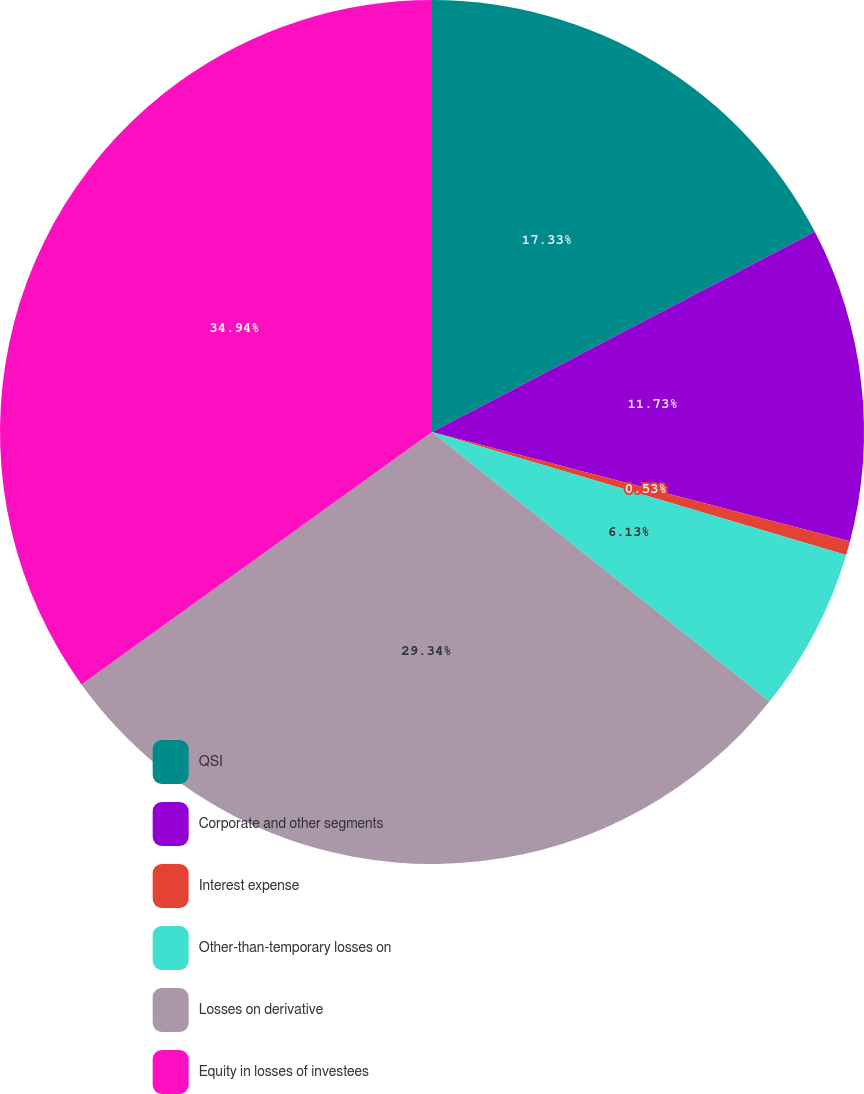Convert chart to OTSL. <chart><loc_0><loc_0><loc_500><loc_500><pie_chart><fcel>QSI<fcel>Corporate and other segments<fcel>Interest expense<fcel>Other-than-temporary losses on<fcel>Losses on derivative<fcel>Equity in losses of investees<nl><fcel>17.33%<fcel>11.73%<fcel>0.53%<fcel>6.13%<fcel>29.33%<fcel>34.93%<nl></chart> 